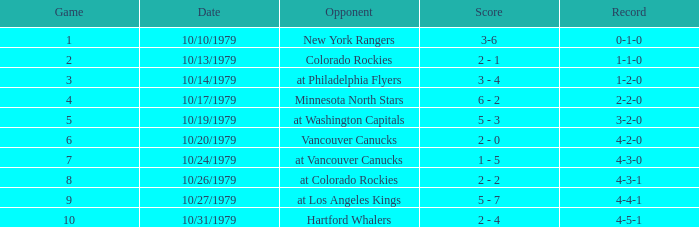What date is the record 4-3-0? 10/24/1979. 